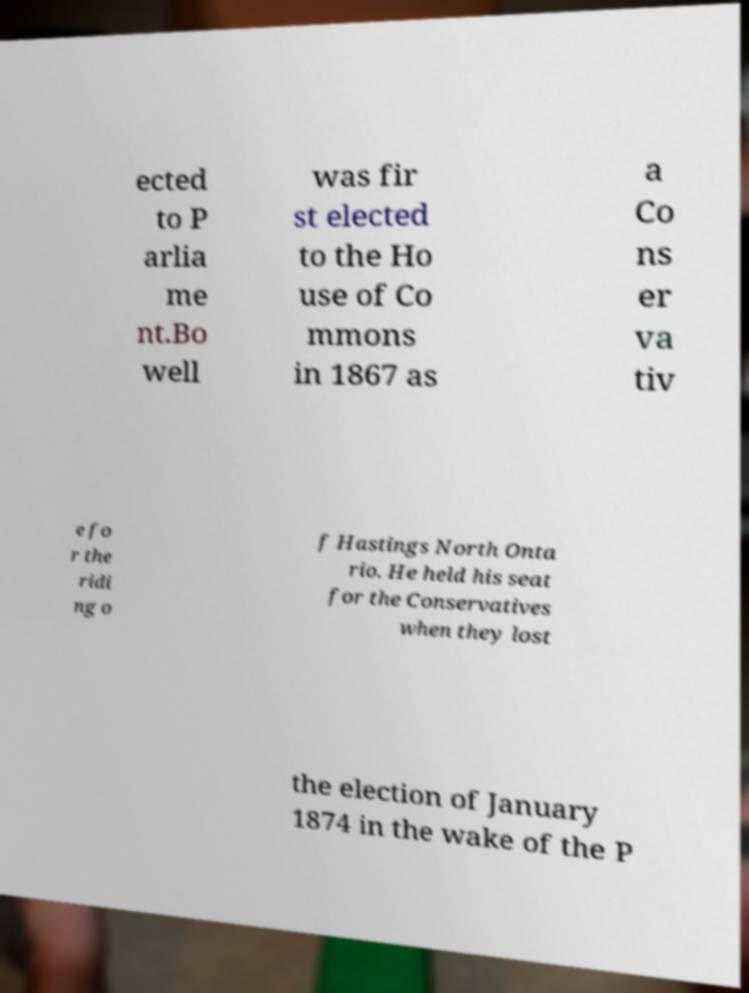I need the written content from this picture converted into text. Can you do that? ected to P arlia me nt.Bo well was fir st elected to the Ho use of Co mmons in 1867 as a Co ns er va tiv e fo r the ridi ng o f Hastings North Onta rio. He held his seat for the Conservatives when they lost the election of January 1874 in the wake of the P 